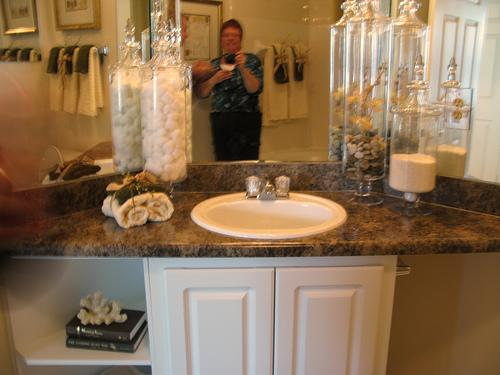What material are the white rounds in the jar made of?

Choices:
A) paper
B) plastic
C) cotton
D) ice cotton 